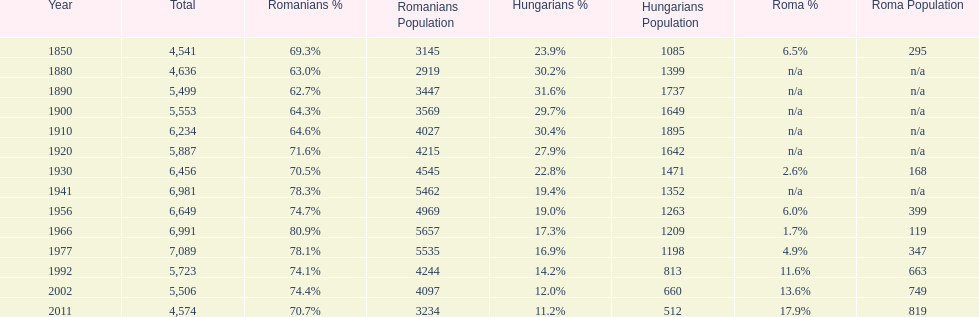Would you mind parsing the complete table? {'header': ['Year', 'Total', 'Romanians %', 'Romanians Population', 'Hungarians %', 'Hungarians Population', 'Roma %', 'Roma Population'], 'rows': [['1850', '4,541', '69.3%', '3145', '23.9%', '1085', '6.5%', '295'], ['1880', '4,636', '63.0%', '2919', '30.2%', '1399', 'n/a', 'n/a'], ['1890', '5,499', '62.7%', '3447', '31.6%', '1737', 'n/a', 'n/a'], ['1900', '5,553', '64.3%', '3569', '29.7%', '1649', 'n/a', 'n/a'], ['1910', '6,234', '64.6%', '4027', '30.4%', '1895', 'n/a', 'n/a'], ['1920', '5,887', '71.6%', '4215', '27.9%', '1642', 'n/a', 'n/a'], ['1930', '6,456', '70.5%', '4545', '22.8%', '1471', '2.6%', '168'], ['1941', '6,981', '78.3%', '5462', '19.4%', '1352', 'n/a', 'n/a'], ['1956', '6,649', '74.7%', '4969', '19.0%', '1263', '6.0%', '399'], ['1966', '6,991', '80.9%', '5657', '17.3%', '1209', '1.7%', '119'], ['1977', '7,089', '78.1%', '5535', '16.9%', '1198', '4.9%', '347'], ['1992', '5,723', '74.1%', '4244', '14.2%', '813', '11.6%', '663'], ['2002', '5,506', '74.4%', '4097', '12.0%', '660', '13.6%', '749'], ['2011', '4,574', '70.7%', '3234', '11.2%', '512', '17.9%', '819']]} What percent of the population were romanians according to the last year on this chart? 70.7%. 